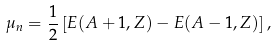<formula> <loc_0><loc_0><loc_500><loc_500>\mu _ { n } = \frac { 1 } { 2 } \left [ E ( A + 1 , Z ) - E ( A - 1 , Z ) \right ] ,</formula> 